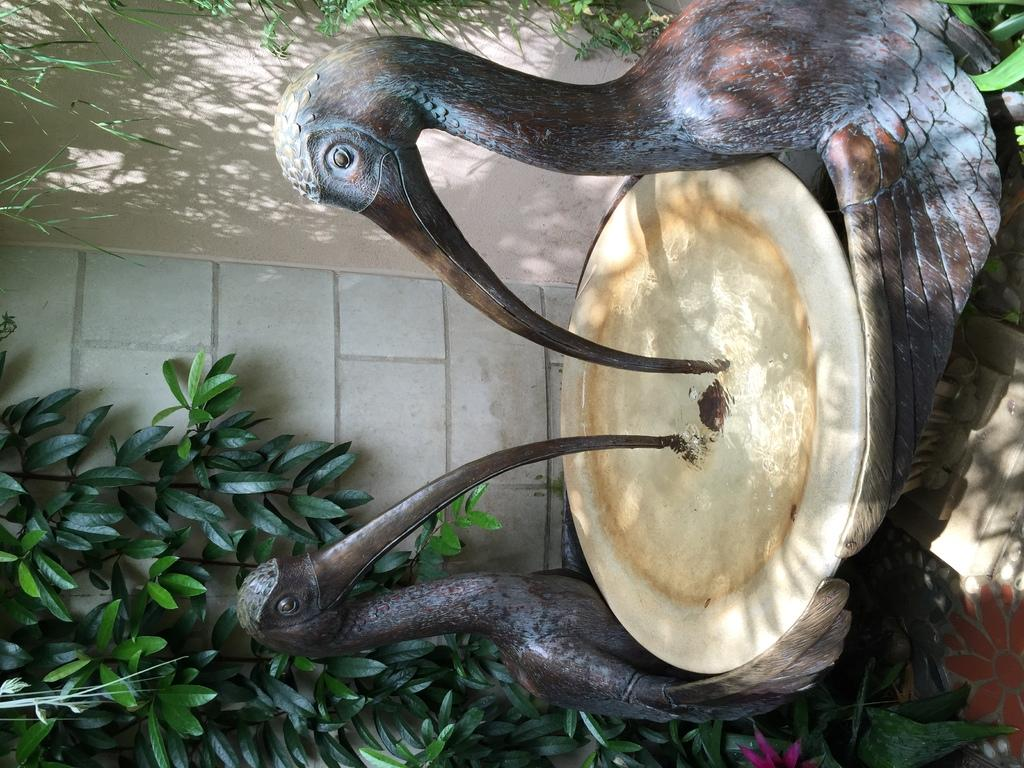What is the main subject of the image? There is a statue in the image. What can be seen on the backside of the statue? There are plants and a wall visible on the backside of the statue. How many chairs are placed around the statue in the image? There are no chairs present in the image; it only features a statue with plants and a wall visible on the backside. 